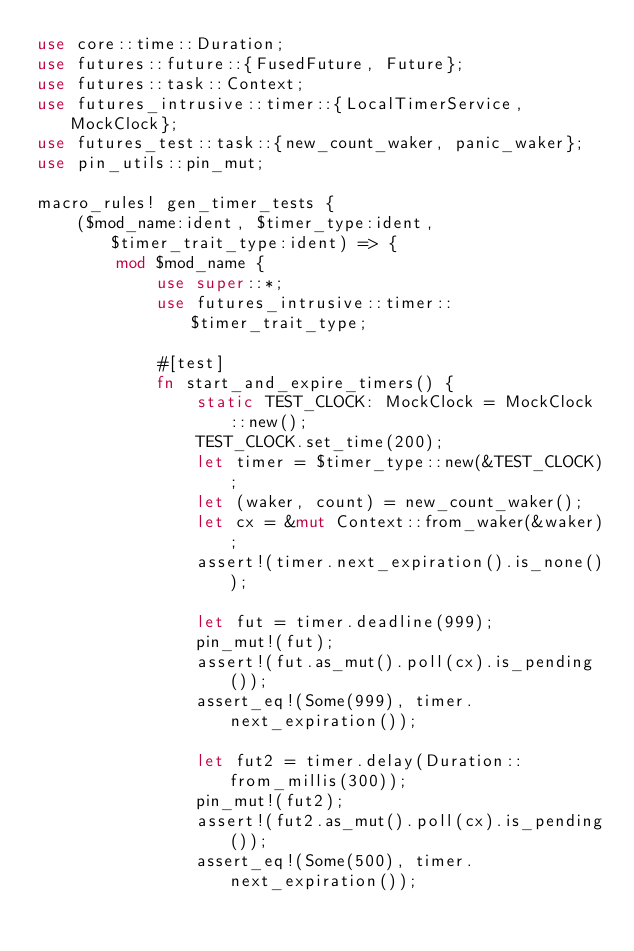Convert code to text. <code><loc_0><loc_0><loc_500><loc_500><_Rust_>use core::time::Duration;
use futures::future::{FusedFuture, Future};
use futures::task::Context;
use futures_intrusive::timer::{LocalTimerService, MockClock};
use futures_test::task::{new_count_waker, panic_waker};
use pin_utils::pin_mut;

macro_rules! gen_timer_tests {
    ($mod_name:ident, $timer_type:ident, $timer_trait_type:ident) => {
        mod $mod_name {
            use super::*;
            use futures_intrusive::timer::$timer_trait_type;

            #[test]
            fn start_and_expire_timers() {
                static TEST_CLOCK: MockClock = MockClock::new();
                TEST_CLOCK.set_time(200);
                let timer = $timer_type::new(&TEST_CLOCK);
                let (waker, count) = new_count_waker();
                let cx = &mut Context::from_waker(&waker);
                assert!(timer.next_expiration().is_none());

                let fut = timer.deadline(999);
                pin_mut!(fut);
                assert!(fut.as_mut().poll(cx).is_pending());
                assert_eq!(Some(999), timer.next_expiration());

                let fut2 = timer.delay(Duration::from_millis(300));
                pin_mut!(fut2);
                assert!(fut2.as_mut().poll(cx).is_pending());
                assert_eq!(Some(500), timer.next_expiration());
</code> 